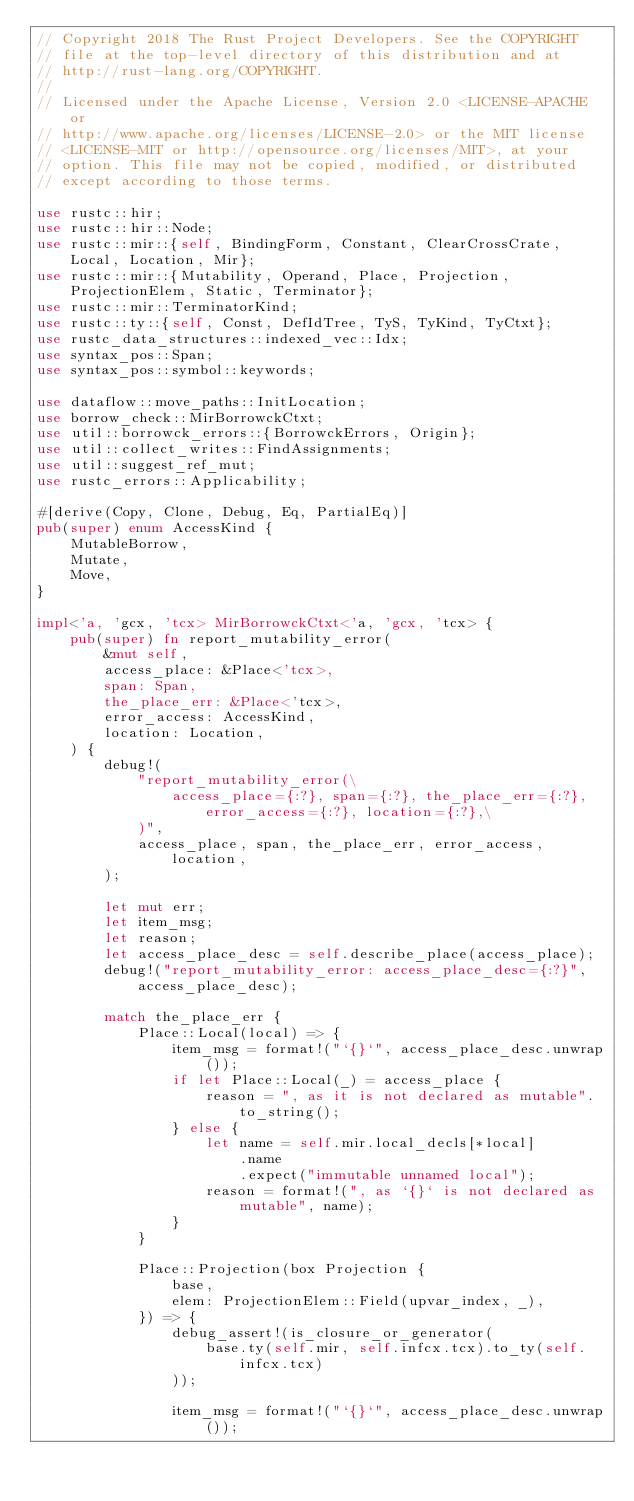<code> <loc_0><loc_0><loc_500><loc_500><_Rust_>// Copyright 2018 The Rust Project Developers. See the COPYRIGHT
// file at the top-level directory of this distribution and at
// http://rust-lang.org/COPYRIGHT.
//
// Licensed under the Apache License, Version 2.0 <LICENSE-APACHE or
// http://www.apache.org/licenses/LICENSE-2.0> or the MIT license
// <LICENSE-MIT or http://opensource.org/licenses/MIT>, at your
// option. This file may not be copied, modified, or distributed
// except according to those terms.

use rustc::hir;
use rustc::hir::Node;
use rustc::mir::{self, BindingForm, Constant, ClearCrossCrate, Local, Location, Mir};
use rustc::mir::{Mutability, Operand, Place, Projection, ProjectionElem, Static, Terminator};
use rustc::mir::TerminatorKind;
use rustc::ty::{self, Const, DefIdTree, TyS, TyKind, TyCtxt};
use rustc_data_structures::indexed_vec::Idx;
use syntax_pos::Span;
use syntax_pos::symbol::keywords;

use dataflow::move_paths::InitLocation;
use borrow_check::MirBorrowckCtxt;
use util::borrowck_errors::{BorrowckErrors, Origin};
use util::collect_writes::FindAssignments;
use util::suggest_ref_mut;
use rustc_errors::Applicability;

#[derive(Copy, Clone, Debug, Eq, PartialEq)]
pub(super) enum AccessKind {
    MutableBorrow,
    Mutate,
    Move,
}

impl<'a, 'gcx, 'tcx> MirBorrowckCtxt<'a, 'gcx, 'tcx> {
    pub(super) fn report_mutability_error(
        &mut self,
        access_place: &Place<'tcx>,
        span: Span,
        the_place_err: &Place<'tcx>,
        error_access: AccessKind,
        location: Location,
    ) {
        debug!(
            "report_mutability_error(\
                access_place={:?}, span={:?}, the_place_err={:?}, error_access={:?}, location={:?},\
            )",
            access_place, span, the_place_err, error_access, location,
        );

        let mut err;
        let item_msg;
        let reason;
        let access_place_desc = self.describe_place(access_place);
        debug!("report_mutability_error: access_place_desc={:?}", access_place_desc);

        match the_place_err {
            Place::Local(local) => {
                item_msg = format!("`{}`", access_place_desc.unwrap());
                if let Place::Local(_) = access_place {
                    reason = ", as it is not declared as mutable".to_string();
                } else {
                    let name = self.mir.local_decls[*local]
                        .name
                        .expect("immutable unnamed local");
                    reason = format!(", as `{}` is not declared as mutable", name);
                }
            }

            Place::Projection(box Projection {
                base,
                elem: ProjectionElem::Field(upvar_index, _),
            }) => {
                debug_assert!(is_closure_or_generator(
                    base.ty(self.mir, self.infcx.tcx).to_ty(self.infcx.tcx)
                ));

                item_msg = format!("`{}`", access_place_desc.unwrap());</code> 